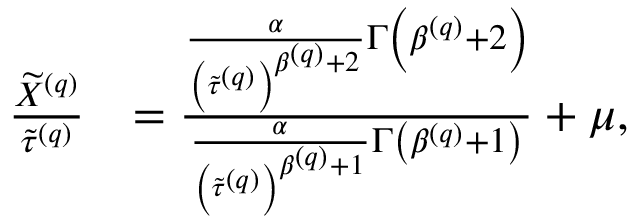<formula> <loc_0><loc_0><loc_500><loc_500>\begin{array} { r l } { \frac { \widetilde { X } ^ { \left ( q \right ) } } { \widetilde { \tau } ^ { \left ( q \right ) } } } & { = \frac { \frac { \alpha } { \left ( \widetilde { \tau } ^ { \left ( q \right ) } \right ) ^ { \beta ^ { \left ( q \right ) } + 2 } } \Gamma \left ( \beta ^ { \left ( q \right ) } + 2 \right ) } { \frac { \alpha } { \left ( \widetilde { \tau } ^ { \left ( q \right ) } \right ) ^ { \beta ^ { \left ( q \right ) } + 1 } } \Gamma \left ( \beta ^ { \left ( q \right ) } + 1 \right ) } + \mu , } \end{array}</formula> 